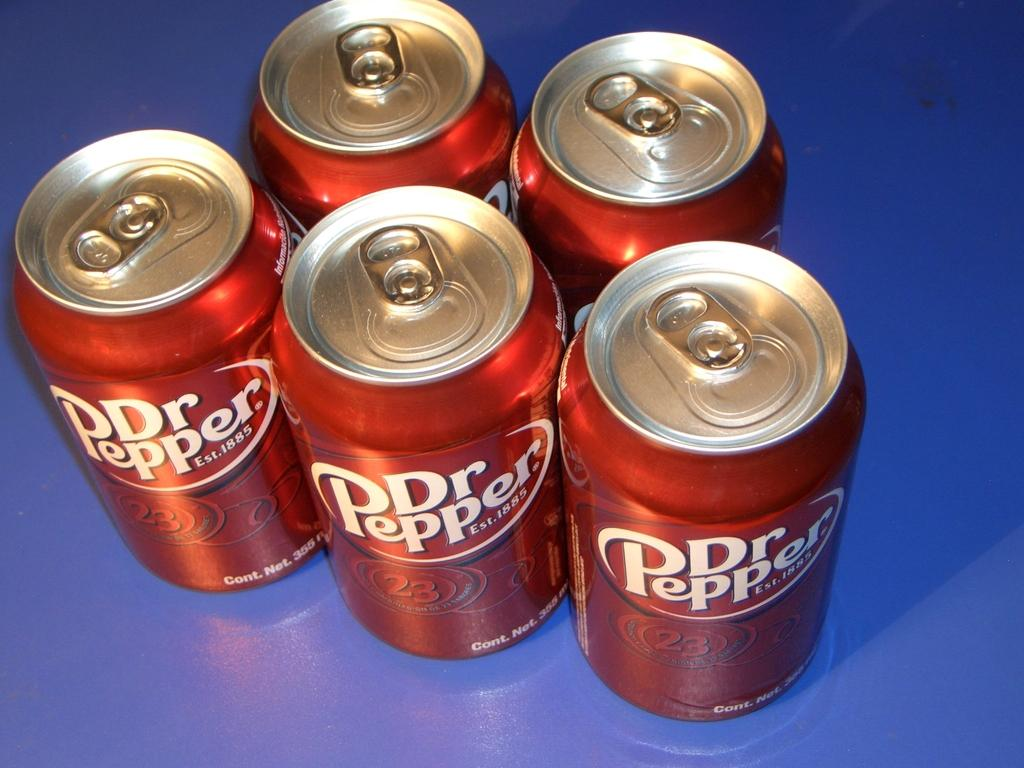<image>
Create a compact narrative representing the image presented. Five red cans of Dr Pepper on a blue background 